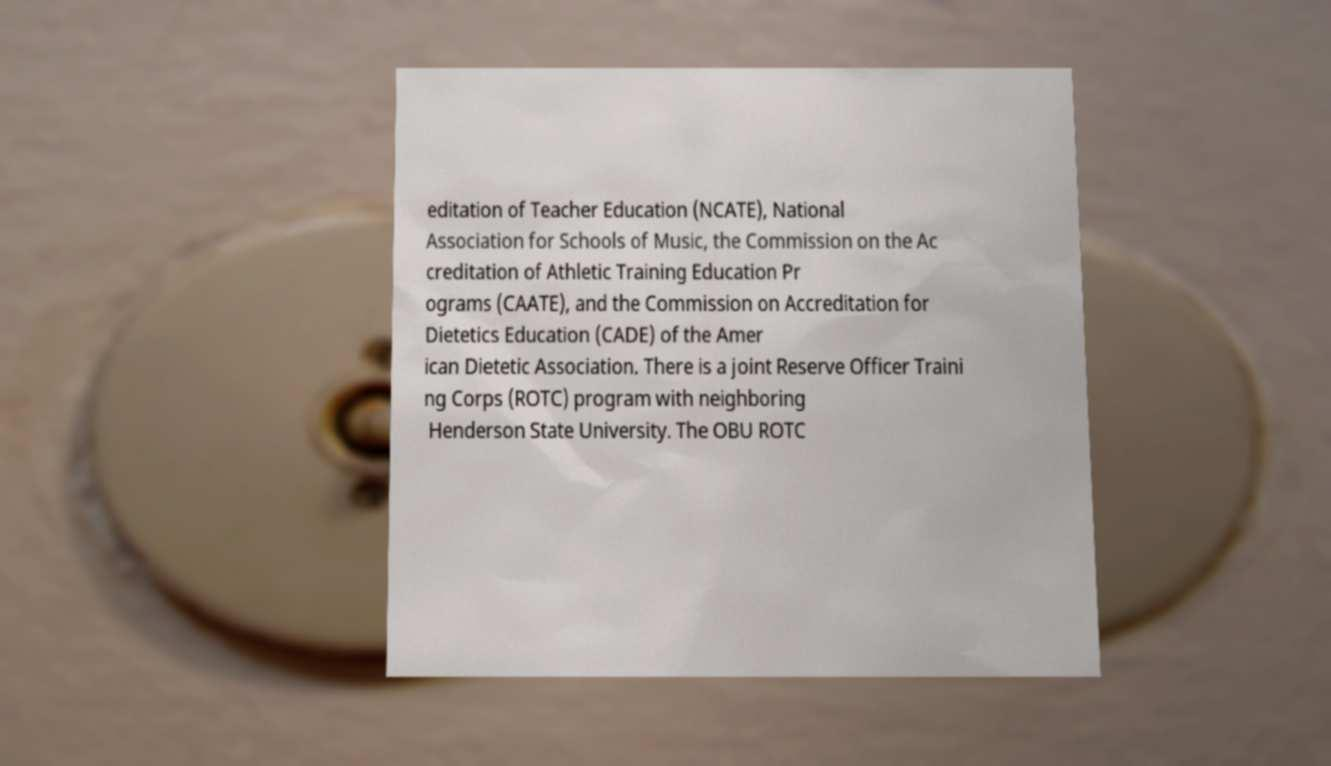Could you extract and type out the text from this image? editation of Teacher Education (NCATE), National Association for Schools of Music, the Commission on the Ac creditation of Athletic Training Education Pr ograms (CAATE), and the Commission on Accreditation for Dietetics Education (CADE) of the Amer ican Dietetic Association. There is a joint Reserve Officer Traini ng Corps (ROTC) program with neighboring Henderson State University. The OBU ROTC 